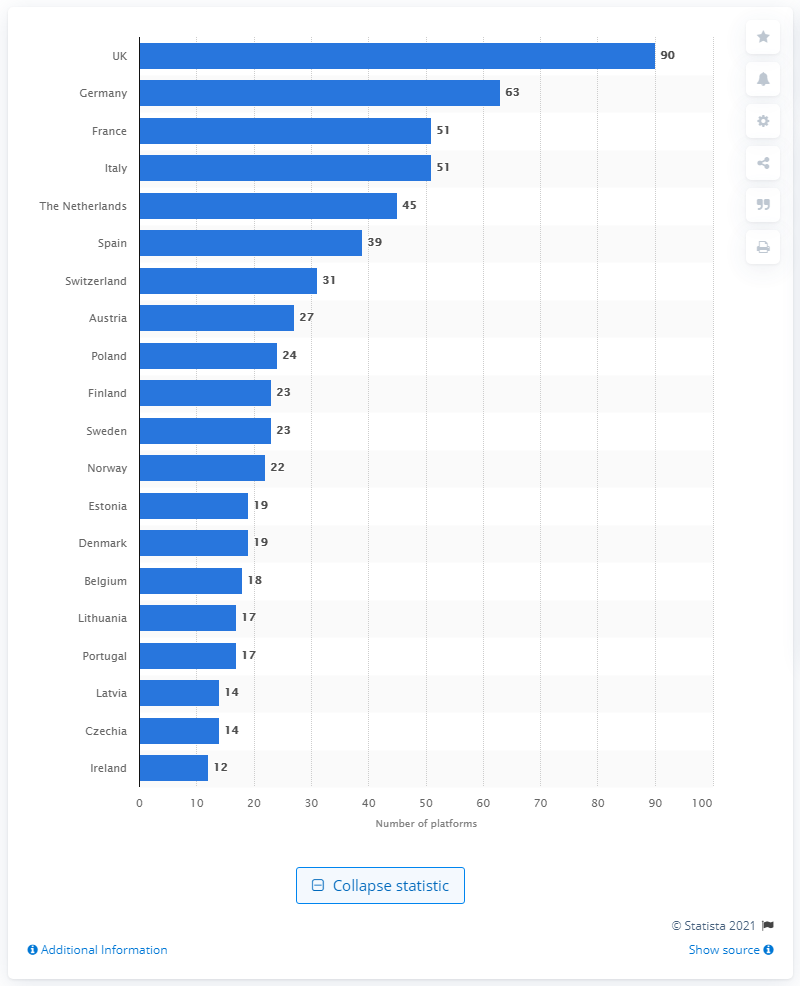Highlight a few significant elements in this photo. There were 63 alternative finance online platforms in Germany in 2018. In 2018, there were 90 alternative finance online platforms operating in the UK. 